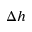<formula> <loc_0><loc_0><loc_500><loc_500>\Delta h</formula> 